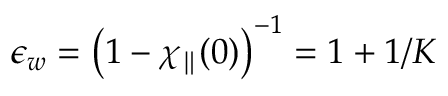Convert formula to latex. <formula><loc_0><loc_0><loc_500><loc_500>\epsilon _ { w } = \left ( 1 - \chi _ { \| } ( 0 ) \right ) ^ { - 1 } = 1 + 1 / K</formula> 